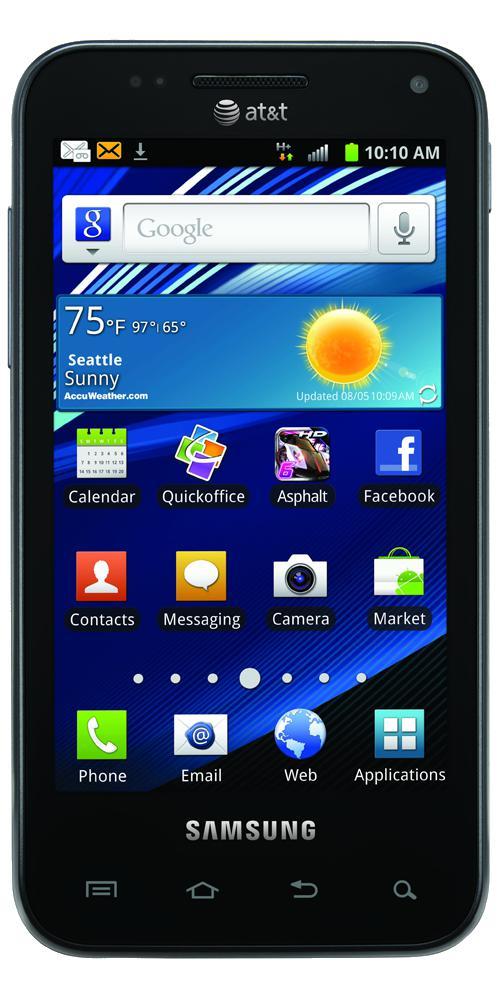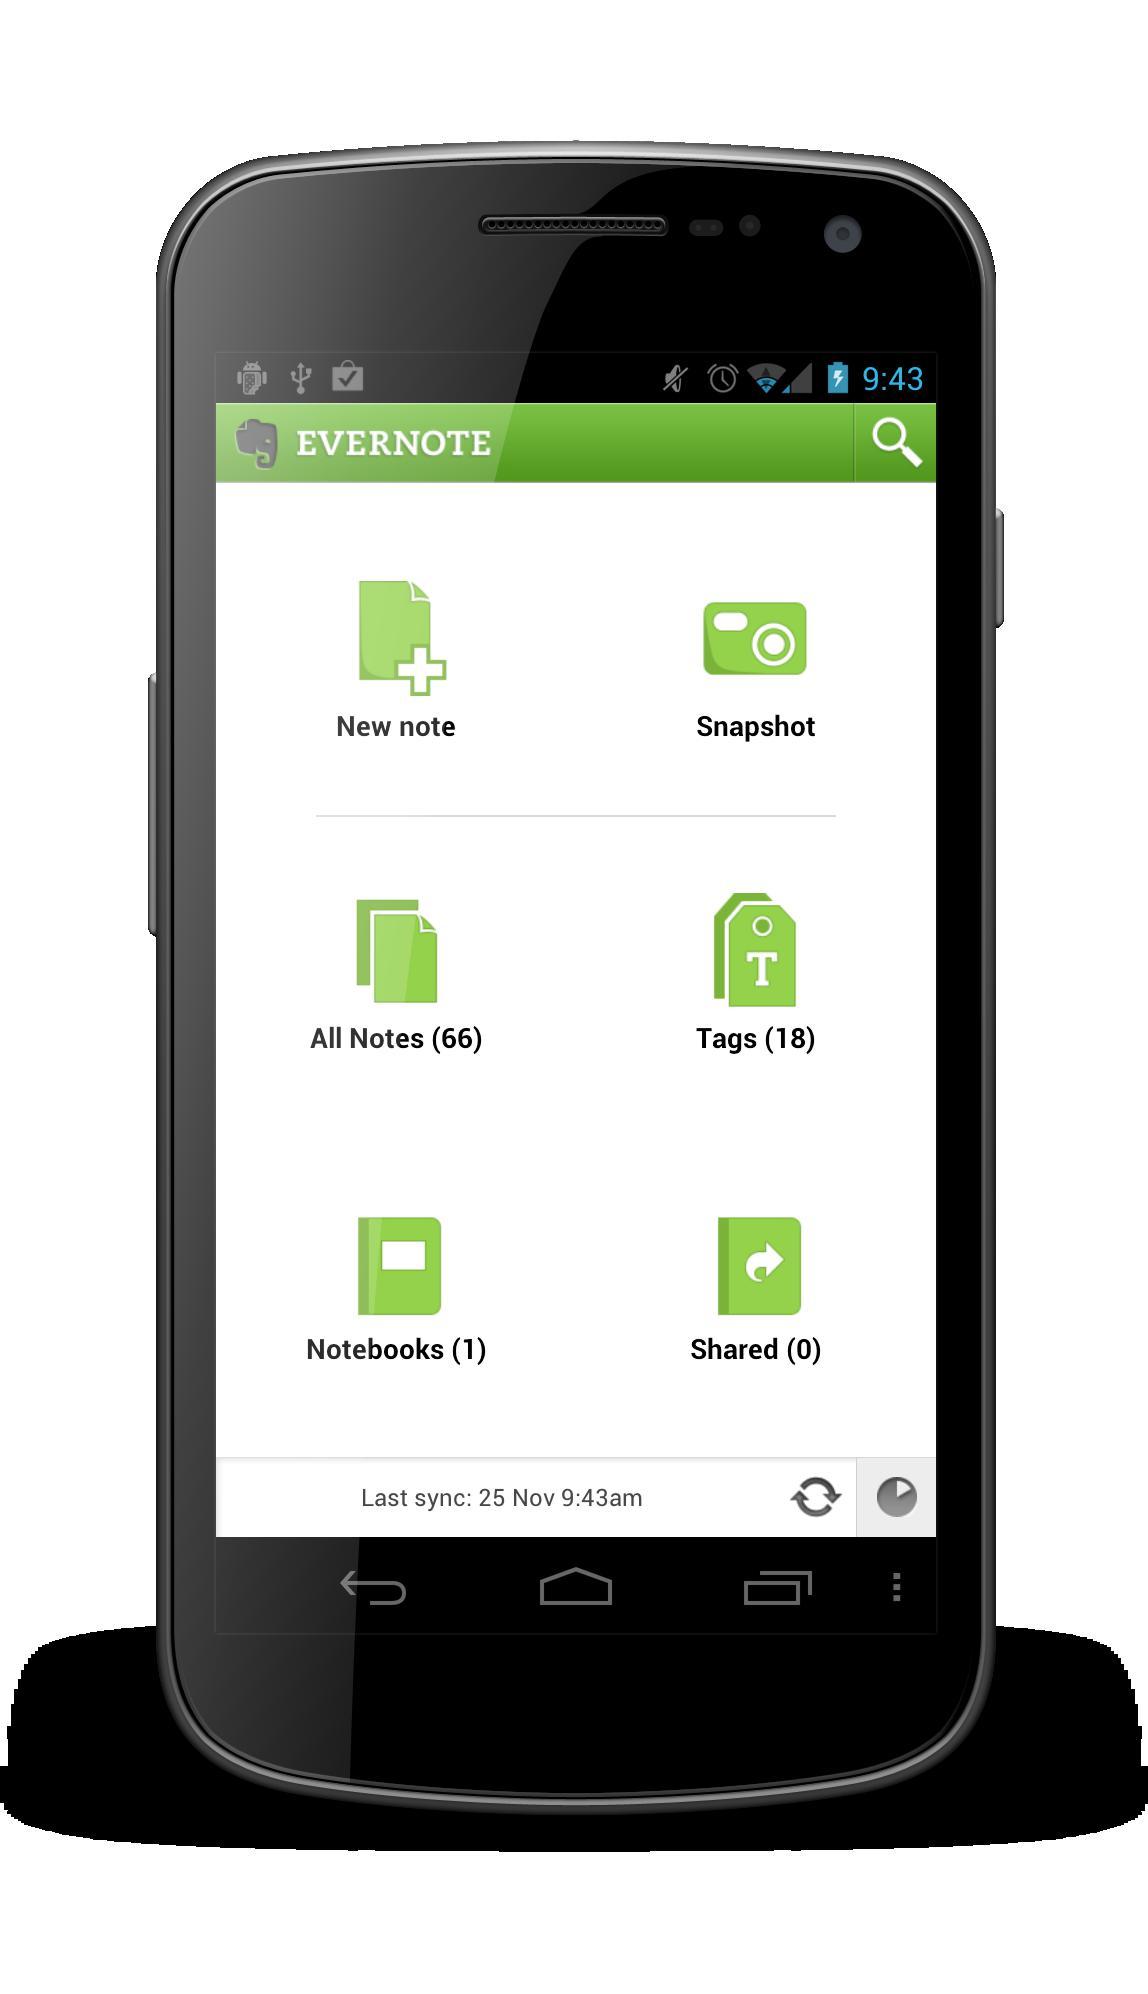The first image is the image on the left, the second image is the image on the right. Evaluate the accuracy of this statement regarding the images: "One of the phones is turned off, with a blank screen.". Is it true? Answer yes or no. No. The first image is the image on the left, the second image is the image on the right. Assess this claim about the two images: "The right image contains one smart phone with a black screen.". Correct or not? Answer yes or no. No. 